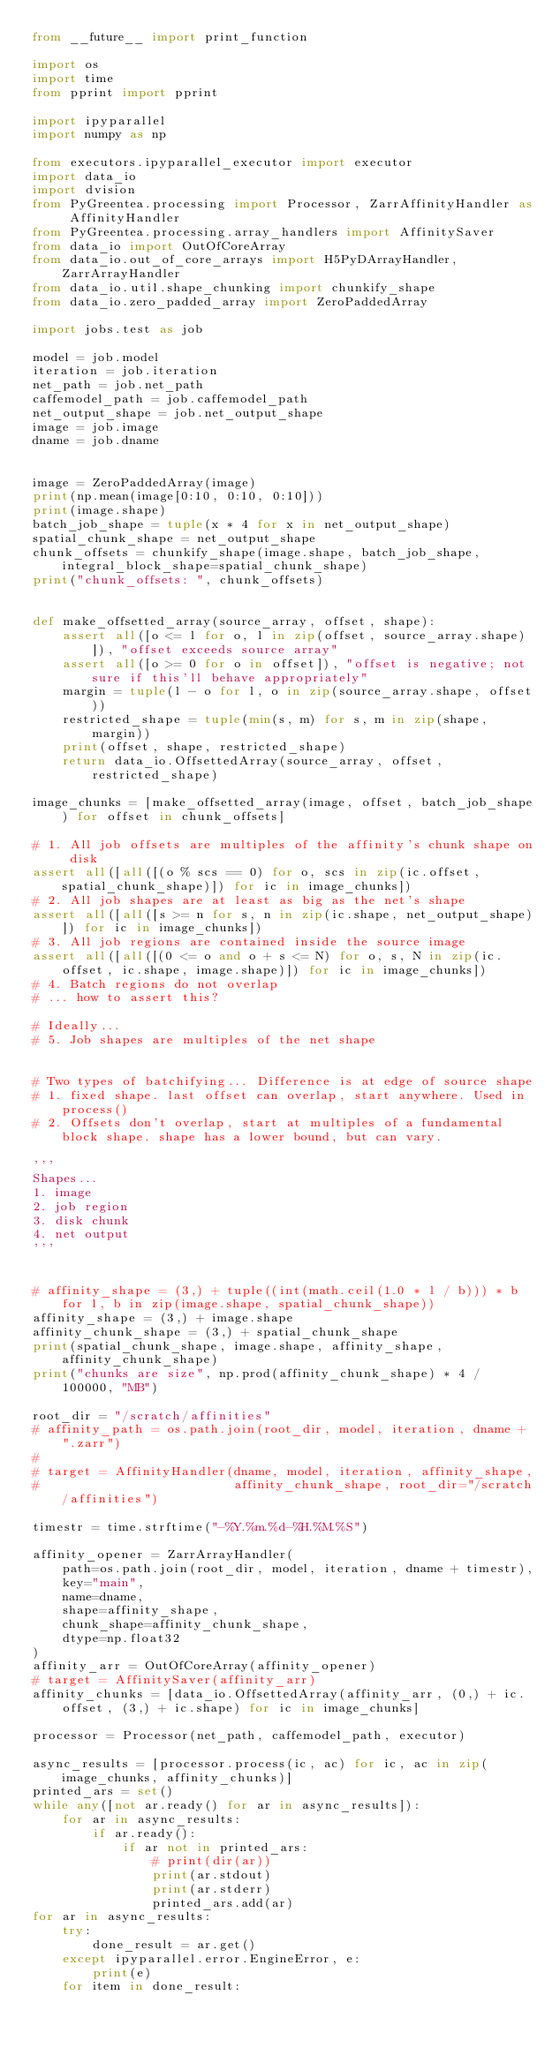<code> <loc_0><loc_0><loc_500><loc_500><_Python_>from __future__ import print_function

import os
import time
from pprint import pprint

import ipyparallel
import numpy as np

from executors.ipyparallel_executor import executor
import data_io
import dvision
from PyGreentea.processing import Processor, ZarrAffinityHandler as AffinityHandler
from PyGreentea.processing.array_handlers import AffinitySaver
from data_io import OutOfCoreArray
from data_io.out_of_core_arrays import H5PyDArrayHandler, ZarrArrayHandler
from data_io.util.shape_chunking import chunkify_shape
from data_io.zero_padded_array import ZeroPaddedArray

import jobs.test as job

model = job.model
iteration = job.iteration
net_path = job.net_path
caffemodel_path = job.caffemodel_path
net_output_shape = job.net_output_shape
image = job.image
dname = job.dname


image = ZeroPaddedArray(image)
print(np.mean(image[0:10, 0:10, 0:10]))
print(image.shape)
batch_job_shape = tuple(x * 4 for x in net_output_shape)
spatial_chunk_shape = net_output_shape
chunk_offsets = chunkify_shape(image.shape, batch_job_shape, integral_block_shape=spatial_chunk_shape)
print("chunk_offsets: ", chunk_offsets)


def make_offsetted_array(source_array, offset, shape):
    assert all([o <= l for o, l in zip(offset, source_array.shape)]), "offset exceeds source array"
    assert all([o >= 0 for o in offset]), "offset is negative; not sure if this'll behave appropriately"
    margin = tuple(l - o for l, o in zip(source_array.shape, offset))
    restricted_shape = tuple(min(s, m) for s, m in zip(shape, margin))
    print(offset, shape, restricted_shape)
    return data_io.OffsettedArray(source_array, offset, restricted_shape)

image_chunks = [make_offsetted_array(image, offset, batch_job_shape) for offset in chunk_offsets]

# 1. All job offsets are multiples of the affinity's chunk shape on disk
assert all([all([(o % scs == 0) for o, scs in zip(ic.offset, spatial_chunk_shape)]) for ic in image_chunks])
# 2. All job shapes are at least as big as the net's shape
assert all([all([s >= n for s, n in zip(ic.shape, net_output_shape)]) for ic in image_chunks])
# 3. All job regions are contained inside the source image
assert all([all([(0 <= o and o + s <= N) for o, s, N in zip(ic.offset, ic.shape, image.shape)]) for ic in image_chunks])
# 4. Batch regions do not overlap
# ... how to assert this?

# Ideally...
# 5. Job shapes are multiples of the net shape


# Two types of batchifying... Difference is at edge of source shape
# 1. fixed shape. last offset can overlap, start anywhere. Used in process()
# 2. Offsets don't overlap, start at multiples of a fundamental block shape. shape has a lower bound, but can vary. 

'''
Shapes...
1. image
2. job region
3. disk chunk
4. net output
'''


# affinity_shape = (3,) + tuple((int(math.ceil(1.0 * l / b))) * b for l, b in zip(image.shape, spatial_chunk_shape))
affinity_shape = (3,) + image.shape
affinity_chunk_shape = (3,) + spatial_chunk_shape
print(spatial_chunk_shape, image.shape, affinity_shape, affinity_chunk_shape)
print("chunks are size", np.prod(affinity_chunk_shape) * 4 / 100000, "MB")

root_dir = "/scratch/affinities"
# affinity_path = os.path.join(root_dir, model, iteration, dname + ".zarr")
#
# target = AffinityHandler(dname, model, iteration, affinity_shape,
#                          affinity_chunk_shape, root_dir="/scratch/affinities")

timestr = time.strftime("-%Y.%m.%d-%H.%M.%S")

affinity_opener = ZarrArrayHandler(
    path=os.path.join(root_dir, model, iteration, dname + timestr),
    key="main",
    name=dname,
    shape=affinity_shape,
    chunk_shape=affinity_chunk_shape,
    dtype=np.float32
)
affinity_arr = OutOfCoreArray(affinity_opener)
# target = AffinitySaver(affinity_arr)
affinity_chunks = [data_io.OffsettedArray(affinity_arr, (0,) + ic.offset, (3,) + ic.shape) for ic in image_chunks]

processor = Processor(net_path, caffemodel_path, executor)

async_results = [processor.process(ic, ac) for ic, ac in zip(image_chunks, affinity_chunks)]
printed_ars = set()
while any([not ar.ready() for ar in async_results]):
    for ar in async_results:
        if ar.ready():
            if ar not in printed_ars:
                # print(dir(ar))
                print(ar.stdout)
                print(ar.stderr)
                printed_ars.add(ar)
for ar in async_results:
    try:
        done_result = ar.get()
    except ipyparallel.error.EngineError, e:
        print(e)
    for item in done_result:</code> 